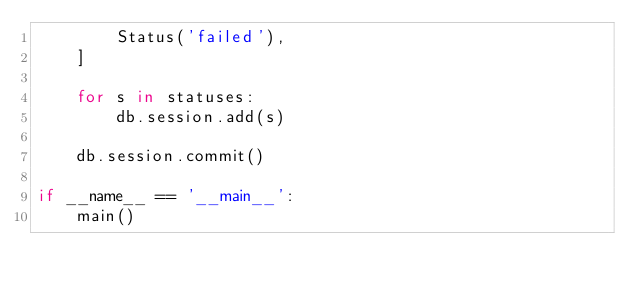Convert code to text. <code><loc_0><loc_0><loc_500><loc_500><_Python_>        Status('failed'),
    ]

    for s in statuses:
        db.session.add(s)

    db.session.commit()

if __name__ == '__main__':
    main()
</code> 